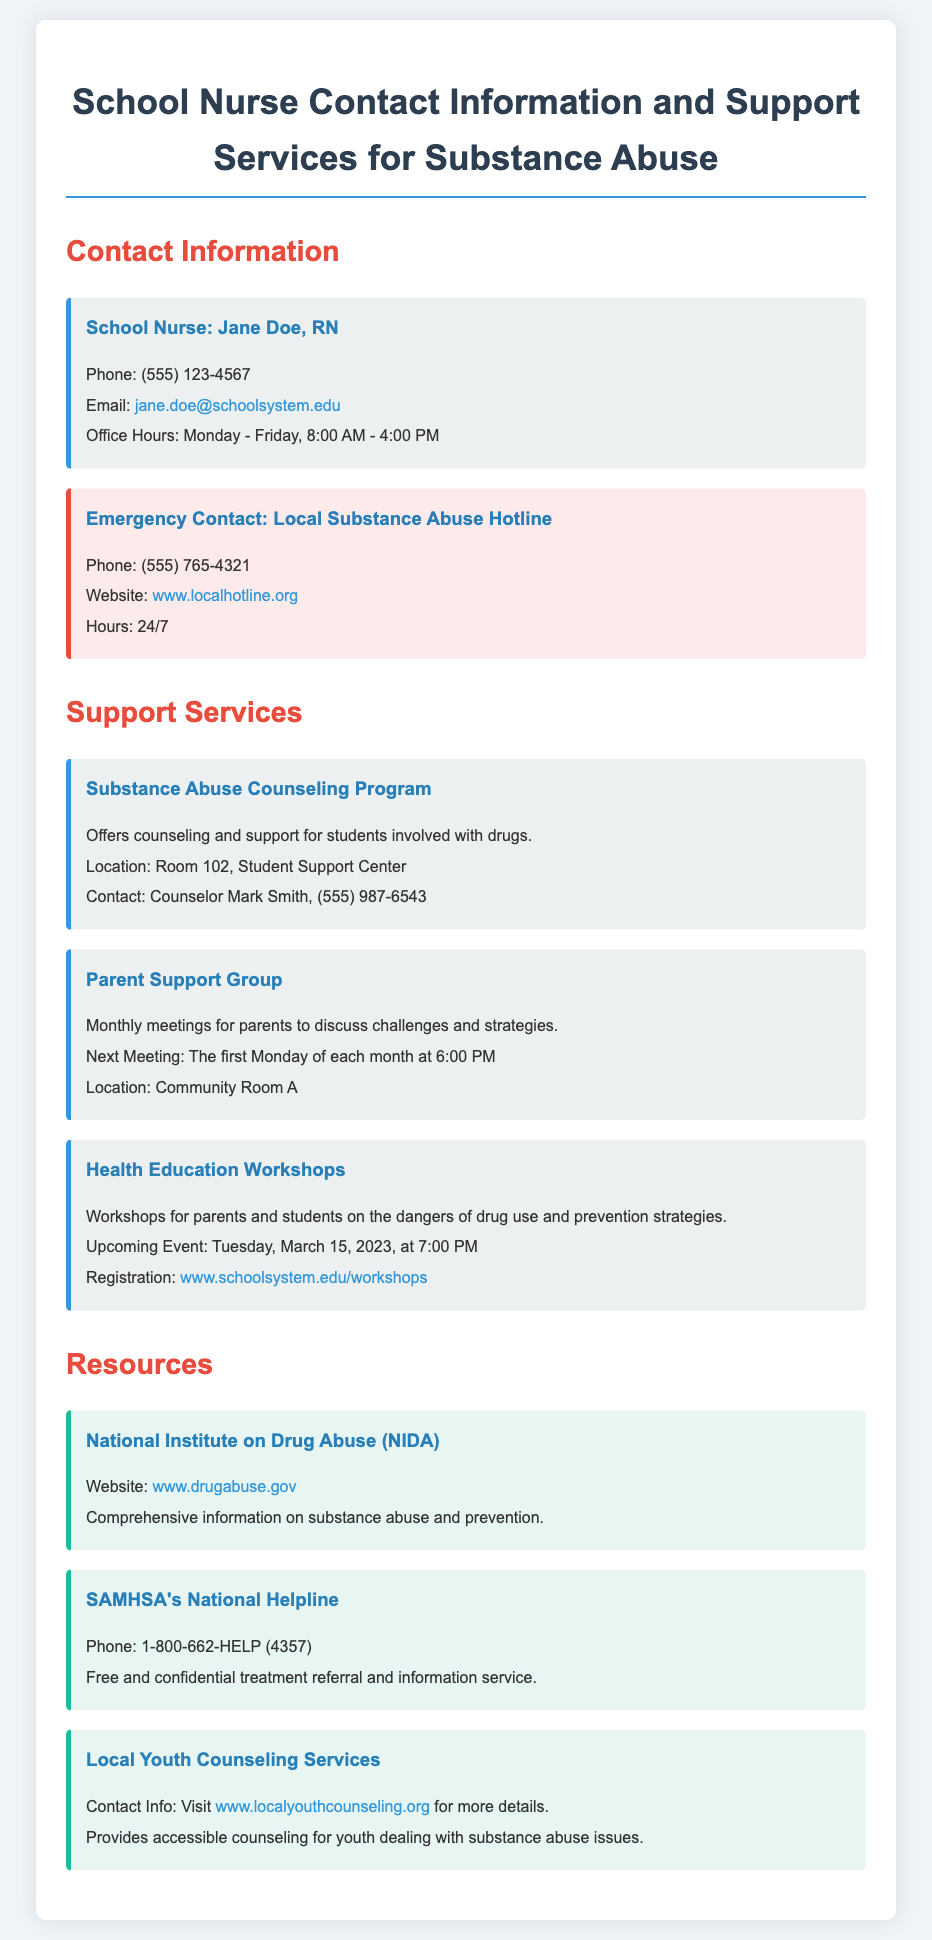what is the name of the school nurse? The document specifies the school nurse's name as Jane Doe.
Answer: Jane Doe what is the phone number for the school nurse? The contact information provided includes the nurse's phone number as (555) 123-4567.
Answer: (555) 123-4567 what are the office hours for the school nurse? The document states the office hours are from Monday to Friday, 8:00 AM to 4:00 PM.
Answer: Monday - Friday, 8:00 AM - 4:00 PM who should be contacted for substance abuse counseling services? Counselor Mark Smith is listed as the contact for substance abuse counseling services.
Answer: Mark Smith when is the next Parent Support Group meeting? The document mentions that the next meeting is on the first Monday of each month at 6:00 PM.
Answer: First Monday of each month at 6:00 PM what is the phone number for the local substance abuse hotline? The emergency contact information states the hotline's phone number as (555) 765-4321.
Answer: (555) 765-4321 what is the focus of the Health Education Workshops? The workshops aim to educate parents and students on the dangers of drug use and prevention strategies.
Answer: Dangers of drug use and prevention strategies what type of support does the Substance Abuse Counseling Program offer? The program offers counseling and support specifically for students involved with drugs.
Answer: Counseling and support for students involved with drugs how can I register for the Health Education Workshops? Registration can be completed through the link provided in the document.
Answer: www.schoolsystem.edu/workshops 